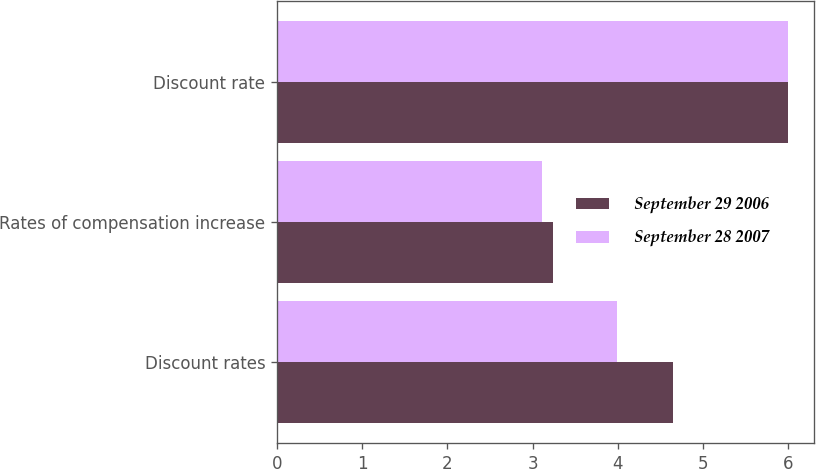Convert chart to OTSL. <chart><loc_0><loc_0><loc_500><loc_500><stacked_bar_chart><ecel><fcel>Discount rates<fcel>Rates of compensation increase<fcel>Discount rate<nl><fcel>September 29 2006<fcel>4.64<fcel>3.24<fcel>6<nl><fcel>September 28 2007<fcel>3.99<fcel>3.11<fcel>6<nl></chart> 